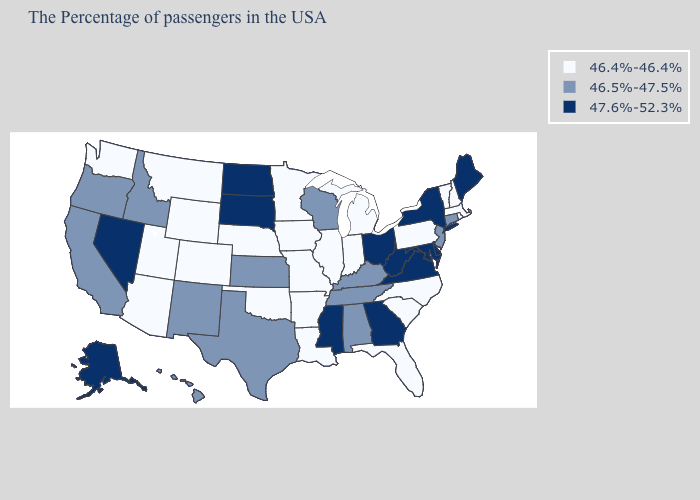Which states hav the highest value in the Northeast?
Concise answer only. Maine, New York. What is the lowest value in states that border Minnesota?
Answer briefly. 46.4%-46.4%. What is the value of Virginia?
Be succinct. 47.6%-52.3%. What is the highest value in states that border Colorado?
Quick response, please. 46.5%-47.5%. Among the states that border Arizona , which have the highest value?
Be succinct. Nevada. Name the states that have a value in the range 46.5%-47.5%?
Concise answer only. Connecticut, New Jersey, Kentucky, Alabama, Tennessee, Wisconsin, Kansas, Texas, New Mexico, Idaho, California, Oregon, Hawaii. What is the value of Texas?
Concise answer only. 46.5%-47.5%. Name the states that have a value in the range 46.5%-47.5%?
Be succinct. Connecticut, New Jersey, Kentucky, Alabama, Tennessee, Wisconsin, Kansas, Texas, New Mexico, Idaho, California, Oregon, Hawaii. What is the value of Minnesota?
Write a very short answer. 46.4%-46.4%. What is the lowest value in the USA?
Quick response, please. 46.4%-46.4%. What is the value of Maine?
Keep it brief. 47.6%-52.3%. What is the value of Georgia?
Concise answer only. 47.6%-52.3%. Name the states that have a value in the range 46.5%-47.5%?
Concise answer only. Connecticut, New Jersey, Kentucky, Alabama, Tennessee, Wisconsin, Kansas, Texas, New Mexico, Idaho, California, Oregon, Hawaii. What is the value of Colorado?
Keep it brief. 46.4%-46.4%. Does the first symbol in the legend represent the smallest category?
Answer briefly. Yes. 